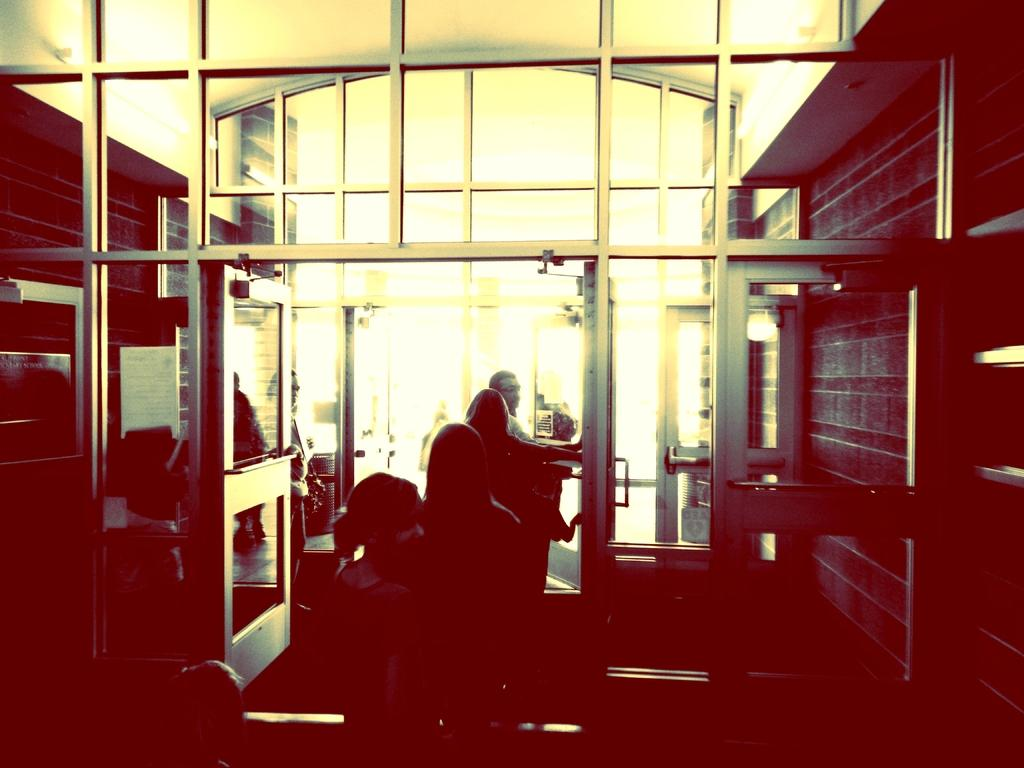What type of setting is shown in the image? The image depicts the interior of the interior of a house. What structural elements can be seen in the image? There are walls visible in the image. Is there any specific feature related to the walls? Yes, there is a glass door in the image. What is the state of the glass door? The glass door is opened. Are there any people present in the image? Yes, there are people standing in the image. Can you see the kitty playing with the mom in the image? There is no kitty or mom present in the image. 